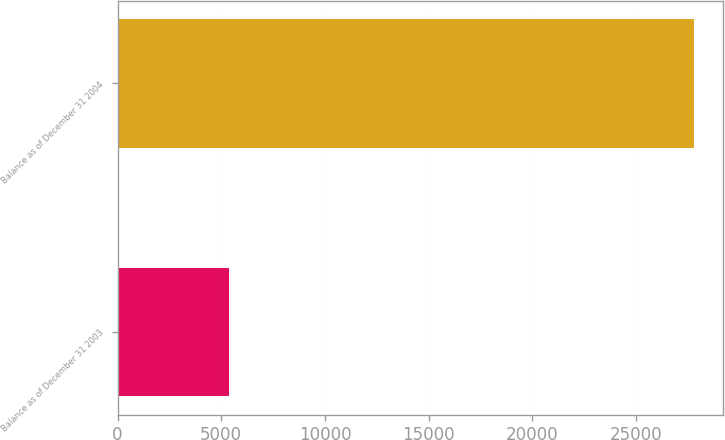Convert chart. <chart><loc_0><loc_0><loc_500><loc_500><bar_chart><fcel>Balance as of December 31 2003<fcel>Balance as of December 31 2004<nl><fcel>5385<fcel>27793<nl></chart> 